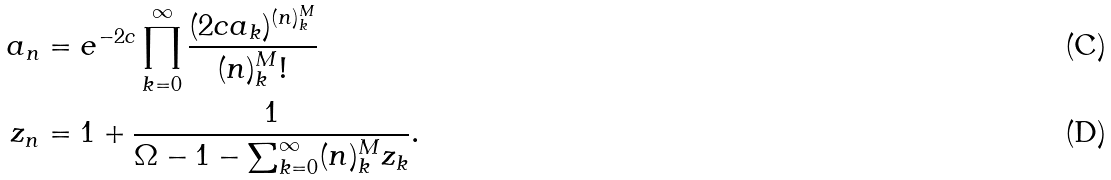<formula> <loc_0><loc_0><loc_500><loc_500>a _ { n } & = e ^ { - 2 c } \prod _ { k = 0 } ^ { \infty } \frac { ( 2 c a _ { k } ) ^ { ( n ) ^ { M } _ { k } } } { ( n ) ^ { M } _ { k } ! } \\ z _ { n } & = 1 + \frac { 1 } { \Omega - 1 - \sum _ { k = 0 } ^ { \infty } ( n ) ^ { M } _ { k } z _ { k } } .</formula> 